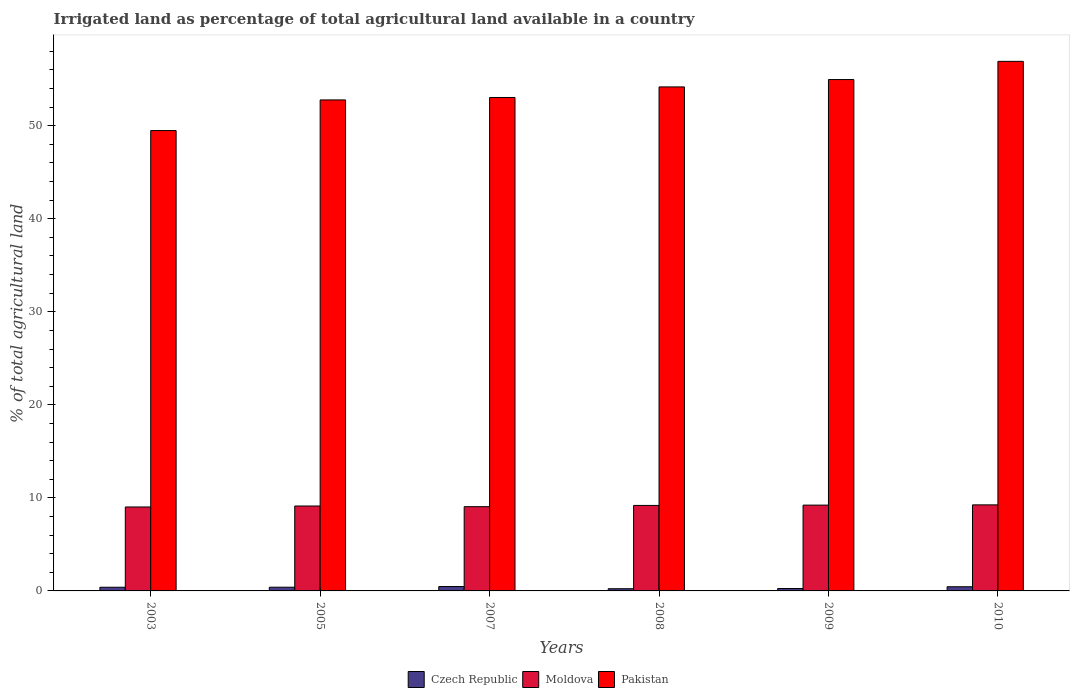How many different coloured bars are there?
Provide a succinct answer. 3. How many groups of bars are there?
Provide a short and direct response. 6. How many bars are there on the 3rd tick from the left?
Give a very brief answer. 3. What is the percentage of irrigated land in Pakistan in 2005?
Make the answer very short. 52.77. Across all years, what is the maximum percentage of irrigated land in Czech Republic?
Keep it short and to the point. 0.47. Across all years, what is the minimum percentage of irrigated land in Pakistan?
Offer a terse response. 49.48. What is the total percentage of irrigated land in Moldova in the graph?
Make the answer very short. 54.87. What is the difference between the percentage of irrigated land in Pakistan in 2008 and that in 2009?
Offer a terse response. -0.79. What is the difference between the percentage of irrigated land in Czech Republic in 2005 and the percentage of irrigated land in Moldova in 2003?
Offer a very short reply. -8.62. What is the average percentage of irrigated land in Pakistan per year?
Offer a terse response. 53.56. In the year 2007, what is the difference between the percentage of irrigated land in Pakistan and percentage of irrigated land in Moldova?
Your response must be concise. 43.98. In how many years, is the percentage of irrigated land in Moldova greater than 18 %?
Give a very brief answer. 0. What is the ratio of the percentage of irrigated land in Moldova in 2008 to that in 2009?
Your answer should be very brief. 1. Is the difference between the percentage of irrigated land in Pakistan in 2005 and 2010 greater than the difference between the percentage of irrigated land in Moldova in 2005 and 2010?
Your answer should be compact. No. What is the difference between the highest and the second highest percentage of irrigated land in Moldova?
Give a very brief answer. 0.03. What is the difference between the highest and the lowest percentage of irrigated land in Moldova?
Provide a succinct answer. 0.23. In how many years, is the percentage of irrigated land in Pakistan greater than the average percentage of irrigated land in Pakistan taken over all years?
Your answer should be compact. 3. What does the 1st bar from the left in 2003 represents?
Provide a succinct answer. Czech Republic. What does the 3rd bar from the right in 2003 represents?
Ensure brevity in your answer.  Czech Republic. How many bars are there?
Provide a short and direct response. 18. How many years are there in the graph?
Give a very brief answer. 6. Does the graph contain any zero values?
Ensure brevity in your answer.  No. Does the graph contain grids?
Provide a short and direct response. No. Where does the legend appear in the graph?
Make the answer very short. Bottom center. How many legend labels are there?
Provide a short and direct response. 3. What is the title of the graph?
Your answer should be compact. Irrigated land as percentage of total agricultural land available in a country. What is the label or title of the Y-axis?
Provide a short and direct response. % of total agricultural land. What is the % of total agricultural land of Czech Republic in 2003?
Make the answer very short. 0.4. What is the % of total agricultural land in Moldova in 2003?
Your answer should be very brief. 9.02. What is the % of total agricultural land of Pakistan in 2003?
Your answer should be very brief. 49.48. What is the % of total agricultural land of Czech Republic in 2005?
Your response must be concise. 0.4. What is the % of total agricultural land of Moldova in 2005?
Offer a terse response. 9.13. What is the % of total agricultural land of Pakistan in 2005?
Your answer should be very brief. 52.77. What is the % of total agricultural land of Czech Republic in 2007?
Ensure brevity in your answer.  0.47. What is the % of total agricultural land in Moldova in 2007?
Make the answer very short. 9.05. What is the % of total agricultural land in Pakistan in 2007?
Keep it short and to the point. 53.04. What is the % of total agricultural land of Czech Republic in 2008?
Provide a succinct answer. 0.24. What is the % of total agricultural land of Moldova in 2008?
Your answer should be compact. 9.19. What is the % of total agricultural land of Pakistan in 2008?
Your answer should be compact. 54.17. What is the % of total agricultural land in Czech Republic in 2009?
Your answer should be very brief. 0.26. What is the % of total agricultural land of Moldova in 2009?
Ensure brevity in your answer.  9.22. What is the % of total agricultural land in Pakistan in 2009?
Your answer should be very brief. 54.96. What is the % of total agricultural land of Czech Republic in 2010?
Keep it short and to the point. 0.45. What is the % of total agricultural land of Moldova in 2010?
Provide a short and direct response. 9.25. What is the % of total agricultural land of Pakistan in 2010?
Make the answer very short. 56.92. Across all years, what is the maximum % of total agricultural land in Czech Republic?
Provide a short and direct response. 0.47. Across all years, what is the maximum % of total agricultural land of Moldova?
Your response must be concise. 9.25. Across all years, what is the maximum % of total agricultural land in Pakistan?
Give a very brief answer. 56.92. Across all years, what is the minimum % of total agricultural land of Czech Republic?
Provide a succinct answer. 0.24. Across all years, what is the minimum % of total agricultural land of Moldova?
Provide a short and direct response. 9.02. Across all years, what is the minimum % of total agricultural land of Pakistan?
Keep it short and to the point. 49.48. What is the total % of total agricultural land of Czech Republic in the graph?
Offer a terse response. 2.21. What is the total % of total agricultural land in Moldova in the graph?
Give a very brief answer. 54.87. What is the total % of total agricultural land of Pakistan in the graph?
Offer a very short reply. 321.35. What is the difference between the % of total agricultural land in Czech Republic in 2003 and that in 2005?
Keep it short and to the point. -0. What is the difference between the % of total agricultural land of Moldova in 2003 and that in 2005?
Ensure brevity in your answer.  -0.1. What is the difference between the % of total agricultural land in Pakistan in 2003 and that in 2005?
Ensure brevity in your answer.  -3.29. What is the difference between the % of total agricultural land of Czech Republic in 2003 and that in 2007?
Your answer should be very brief. -0.07. What is the difference between the % of total agricultural land in Moldova in 2003 and that in 2007?
Offer a very short reply. -0.03. What is the difference between the % of total agricultural land of Pakistan in 2003 and that in 2007?
Offer a very short reply. -3.55. What is the difference between the % of total agricultural land of Czech Republic in 2003 and that in 2008?
Keep it short and to the point. 0.16. What is the difference between the % of total agricultural land in Moldova in 2003 and that in 2008?
Provide a succinct answer. -0.17. What is the difference between the % of total agricultural land in Pakistan in 2003 and that in 2008?
Provide a succinct answer. -4.69. What is the difference between the % of total agricultural land of Czech Republic in 2003 and that in 2009?
Ensure brevity in your answer.  0.14. What is the difference between the % of total agricultural land of Moldova in 2003 and that in 2009?
Your answer should be very brief. -0.2. What is the difference between the % of total agricultural land of Pakistan in 2003 and that in 2009?
Offer a terse response. -5.48. What is the difference between the % of total agricultural land of Czech Republic in 2003 and that in 2010?
Your answer should be compact. -0.05. What is the difference between the % of total agricultural land of Moldova in 2003 and that in 2010?
Offer a very short reply. -0.23. What is the difference between the % of total agricultural land of Pakistan in 2003 and that in 2010?
Your response must be concise. -7.44. What is the difference between the % of total agricultural land of Czech Republic in 2005 and that in 2007?
Your response must be concise. -0.07. What is the difference between the % of total agricultural land in Moldova in 2005 and that in 2007?
Make the answer very short. 0.07. What is the difference between the % of total agricultural land in Pakistan in 2005 and that in 2007?
Keep it short and to the point. -0.26. What is the difference between the % of total agricultural land of Czech Republic in 2005 and that in 2008?
Your response must be concise. 0.16. What is the difference between the % of total agricultural land in Moldova in 2005 and that in 2008?
Offer a terse response. -0.06. What is the difference between the % of total agricultural land of Pakistan in 2005 and that in 2008?
Provide a succinct answer. -1.4. What is the difference between the % of total agricultural land of Czech Republic in 2005 and that in 2009?
Your response must be concise. 0.14. What is the difference between the % of total agricultural land of Moldova in 2005 and that in 2009?
Your answer should be compact. -0.1. What is the difference between the % of total agricultural land in Pakistan in 2005 and that in 2009?
Keep it short and to the point. -2.19. What is the difference between the % of total agricultural land of Czech Republic in 2005 and that in 2010?
Your answer should be compact. -0.05. What is the difference between the % of total agricultural land of Moldova in 2005 and that in 2010?
Your response must be concise. -0.12. What is the difference between the % of total agricultural land of Pakistan in 2005 and that in 2010?
Offer a very short reply. -4.15. What is the difference between the % of total agricultural land in Czech Republic in 2007 and that in 2008?
Offer a very short reply. 0.24. What is the difference between the % of total agricultural land in Moldova in 2007 and that in 2008?
Your response must be concise. -0.14. What is the difference between the % of total agricultural land in Pakistan in 2007 and that in 2008?
Your answer should be compact. -1.14. What is the difference between the % of total agricultural land in Czech Republic in 2007 and that in 2009?
Give a very brief answer. 0.21. What is the difference between the % of total agricultural land in Moldova in 2007 and that in 2009?
Offer a terse response. -0.17. What is the difference between the % of total agricultural land of Pakistan in 2007 and that in 2009?
Ensure brevity in your answer.  -1.93. What is the difference between the % of total agricultural land of Czech Republic in 2007 and that in 2010?
Your answer should be compact. 0.02. What is the difference between the % of total agricultural land in Moldova in 2007 and that in 2010?
Offer a very short reply. -0.2. What is the difference between the % of total agricultural land of Pakistan in 2007 and that in 2010?
Give a very brief answer. -3.88. What is the difference between the % of total agricultural land of Czech Republic in 2008 and that in 2009?
Your response must be concise. -0.02. What is the difference between the % of total agricultural land of Moldova in 2008 and that in 2009?
Your answer should be very brief. -0.03. What is the difference between the % of total agricultural land of Pakistan in 2008 and that in 2009?
Provide a succinct answer. -0.79. What is the difference between the % of total agricultural land in Czech Republic in 2008 and that in 2010?
Give a very brief answer. -0.21. What is the difference between the % of total agricultural land in Moldova in 2008 and that in 2010?
Your response must be concise. -0.06. What is the difference between the % of total agricultural land of Pakistan in 2008 and that in 2010?
Your response must be concise. -2.75. What is the difference between the % of total agricultural land in Czech Republic in 2009 and that in 2010?
Offer a terse response. -0.19. What is the difference between the % of total agricultural land in Moldova in 2009 and that in 2010?
Provide a succinct answer. -0.03. What is the difference between the % of total agricultural land of Pakistan in 2009 and that in 2010?
Make the answer very short. -1.96. What is the difference between the % of total agricultural land in Czech Republic in 2003 and the % of total agricultural land in Moldova in 2005?
Your answer should be compact. -8.73. What is the difference between the % of total agricultural land in Czech Republic in 2003 and the % of total agricultural land in Pakistan in 2005?
Offer a terse response. -52.38. What is the difference between the % of total agricultural land in Moldova in 2003 and the % of total agricultural land in Pakistan in 2005?
Offer a very short reply. -43.75. What is the difference between the % of total agricultural land of Czech Republic in 2003 and the % of total agricultural land of Moldova in 2007?
Your response must be concise. -8.66. What is the difference between the % of total agricultural land in Czech Republic in 2003 and the % of total agricultural land in Pakistan in 2007?
Make the answer very short. -52.64. What is the difference between the % of total agricultural land of Moldova in 2003 and the % of total agricultural land of Pakistan in 2007?
Ensure brevity in your answer.  -44.01. What is the difference between the % of total agricultural land in Czech Republic in 2003 and the % of total agricultural land in Moldova in 2008?
Your response must be concise. -8.79. What is the difference between the % of total agricultural land in Czech Republic in 2003 and the % of total agricultural land in Pakistan in 2008?
Offer a terse response. -53.78. What is the difference between the % of total agricultural land of Moldova in 2003 and the % of total agricultural land of Pakistan in 2008?
Give a very brief answer. -45.15. What is the difference between the % of total agricultural land of Czech Republic in 2003 and the % of total agricultural land of Moldova in 2009?
Provide a succinct answer. -8.83. What is the difference between the % of total agricultural land in Czech Republic in 2003 and the % of total agricultural land in Pakistan in 2009?
Provide a succinct answer. -54.57. What is the difference between the % of total agricultural land of Moldova in 2003 and the % of total agricultural land of Pakistan in 2009?
Offer a terse response. -45.94. What is the difference between the % of total agricultural land in Czech Republic in 2003 and the % of total agricultural land in Moldova in 2010?
Keep it short and to the point. -8.85. What is the difference between the % of total agricultural land of Czech Republic in 2003 and the % of total agricultural land of Pakistan in 2010?
Make the answer very short. -56.52. What is the difference between the % of total agricultural land in Moldova in 2003 and the % of total agricultural land in Pakistan in 2010?
Keep it short and to the point. -47.9. What is the difference between the % of total agricultural land of Czech Republic in 2005 and the % of total agricultural land of Moldova in 2007?
Make the answer very short. -8.66. What is the difference between the % of total agricultural land in Czech Republic in 2005 and the % of total agricultural land in Pakistan in 2007?
Ensure brevity in your answer.  -52.64. What is the difference between the % of total agricultural land in Moldova in 2005 and the % of total agricultural land in Pakistan in 2007?
Your answer should be very brief. -43.91. What is the difference between the % of total agricultural land in Czech Republic in 2005 and the % of total agricultural land in Moldova in 2008?
Make the answer very short. -8.79. What is the difference between the % of total agricultural land in Czech Republic in 2005 and the % of total agricultural land in Pakistan in 2008?
Provide a succinct answer. -53.77. What is the difference between the % of total agricultural land in Moldova in 2005 and the % of total agricultural land in Pakistan in 2008?
Your answer should be compact. -45.05. What is the difference between the % of total agricultural land in Czech Republic in 2005 and the % of total agricultural land in Moldova in 2009?
Offer a very short reply. -8.82. What is the difference between the % of total agricultural land of Czech Republic in 2005 and the % of total agricultural land of Pakistan in 2009?
Offer a terse response. -54.57. What is the difference between the % of total agricultural land in Moldova in 2005 and the % of total agricultural land in Pakistan in 2009?
Your response must be concise. -45.84. What is the difference between the % of total agricultural land in Czech Republic in 2005 and the % of total agricultural land in Moldova in 2010?
Provide a short and direct response. -8.85. What is the difference between the % of total agricultural land in Czech Republic in 2005 and the % of total agricultural land in Pakistan in 2010?
Your answer should be compact. -56.52. What is the difference between the % of total agricultural land of Moldova in 2005 and the % of total agricultural land of Pakistan in 2010?
Provide a short and direct response. -47.79. What is the difference between the % of total agricultural land in Czech Republic in 2007 and the % of total agricultural land in Moldova in 2008?
Provide a short and direct response. -8.72. What is the difference between the % of total agricultural land in Czech Republic in 2007 and the % of total agricultural land in Pakistan in 2008?
Ensure brevity in your answer.  -53.7. What is the difference between the % of total agricultural land of Moldova in 2007 and the % of total agricultural land of Pakistan in 2008?
Give a very brief answer. -45.12. What is the difference between the % of total agricultural land in Czech Republic in 2007 and the % of total agricultural land in Moldova in 2009?
Provide a short and direct response. -8.75. What is the difference between the % of total agricultural land in Czech Republic in 2007 and the % of total agricultural land in Pakistan in 2009?
Your answer should be compact. -54.49. What is the difference between the % of total agricultural land of Moldova in 2007 and the % of total agricultural land of Pakistan in 2009?
Provide a short and direct response. -45.91. What is the difference between the % of total agricultural land of Czech Republic in 2007 and the % of total agricultural land of Moldova in 2010?
Provide a succinct answer. -8.78. What is the difference between the % of total agricultural land of Czech Republic in 2007 and the % of total agricultural land of Pakistan in 2010?
Provide a short and direct response. -56.45. What is the difference between the % of total agricultural land in Moldova in 2007 and the % of total agricultural land in Pakistan in 2010?
Provide a succinct answer. -47.87. What is the difference between the % of total agricultural land of Czech Republic in 2008 and the % of total agricultural land of Moldova in 2009?
Offer a terse response. -8.99. What is the difference between the % of total agricultural land in Czech Republic in 2008 and the % of total agricultural land in Pakistan in 2009?
Keep it short and to the point. -54.73. What is the difference between the % of total agricultural land in Moldova in 2008 and the % of total agricultural land in Pakistan in 2009?
Offer a very short reply. -45.78. What is the difference between the % of total agricultural land of Czech Republic in 2008 and the % of total agricultural land of Moldova in 2010?
Offer a very short reply. -9.01. What is the difference between the % of total agricultural land in Czech Republic in 2008 and the % of total agricultural land in Pakistan in 2010?
Provide a short and direct response. -56.69. What is the difference between the % of total agricultural land in Moldova in 2008 and the % of total agricultural land in Pakistan in 2010?
Provide a short and direct response. -47.73. What is the difference between the % of total agricultural land in Czech Republic in 2009 and the % of total agricultural land in Moldova in 2010?
Provide a short and direct response. -8.99. What is the difference between the % of total agricultural land in Czech Republic in 2009 and the % of total agricultural land in Pakistan in 2010?
Make the answer very short. -56.66. What is the difference between the % of total agricultural land of Moldova in 2009 and the % of total agricultural land of Pakistan in 2010?
Your answer should be very brief. -47.7. What is the average % of total agricultural land in Czech Republic per year?
Provide a short and direct response. 0.37. What is the average % of total agricultural land of Moldova per year?
Keep it short and to the point. 9.14. What is the average % of total agricultural land in Pakistan per year?
Keep it short and to the point. 53.56. In the year 2003, what is the difference between the % of total agricultural land in Czech Republic and % of total agricultural land in Moldova?
Provide a succinct answer. -8.63. In the year 2003, what is the difference between the % of total agricultural land of Czech Republic and % of total agricultural land of Pakistan?
Ensure brevity in your answer.  -49.09. In the year 2003, what is the difference between the % of total agricultural land in Moldova and % of total agricultural land in Pakistan?
Your response must be concise. -40.46. In the year 2005, what is the difference between the % of total agricultural land in Czech Republic and % of total agricultural land in Moldova?
Keep it short and to the point. -8.73. In the year 2005, what is the difference between the % of total agricultural land in Czech Republic and % of total agricultural land in Pakistan?
Keep it short and to the point. -52.37. In the year 2005, what is the difference between the % of total agricultural land of Moldova and % of total agricultural land of Pakistan?
Ensure brevity in your answer.  -43.65. In the year 2007, what is the difference between the % of total agricultural land in Czech Republic and % of total agricultural land in Moldova?
Ensure brevity in your answer.  -8.58. In the year 2007, what is the difference between the % of total agricultural land in Czech Republic and % of total agricultural land in Pakistan?
Provide a succinct answer. -52.57. In the year 2007, what is the difference between the % of total agricultural land in Moldova and % of total agricultural land in Pakistan?
Your response must be concise. -43.98. In the year 2008, what is the difference between the % of total agricultural land in Czech Republic and % of total agricultural land in Moldova?
Offer a terse response. -8.95. In the year 2008, what is the difference between the % of total agricultural land in Czech Republic and % of total agricultural land in Pakistan?
Provide a short and direct response. -53.94. In the year 2008, what is the difference between the % of total agricultural land of Moldova and % of total agricultural land of Pakistan?
Your answer should be compact. -44.98. In the year 2009, what is the difference between the % of total agricultural land of Czech Republic and % of total agricultural land of Moldova?
Offer a terse response. -8.96. In the year 2009, what is the difference between the % of total agricultural land in Czech Republic and % of total agricultural land in Pakistan?
Ensure brevity in your answer.  -54.71. In the year 2009, what is the difference between the % of total agricultural land in Moldova and % of total agricultural land in Pakistan?
Ensure brevity in your answer.  -45.74. In the year 2010, what is the difference between the % of total agricultural land in Czech Republic and % of total agricultural land in Moldova?
Your answer should be very brief. -8.8. In the year 2010, what is the difference between the % of total agricultural land in Czech Republic and % of total agricultural land in Pakistan?
Give a very brief answer. -56.47. In the year 2010, what is the difference between the % of total agricultural land of Moldova and % of total agricultural land of Pakistan?
Offer a terse response. -47.67. What is the ratio of the % of total agricultural land in Czech Republic in 2003 to that in 2005?
Provide a succinct answer. 0.99. What is the ratio of the % of total agricultural land in Moldova in 2003 to that in 2005?
Your answer should be compact. 0.99. What is the ratio of the % of total agricultural land of Pakistan in 2003 to that in 2005?
Keep it short and to the point. 0.94. What is the ratio of the % of total agricultural land of Czech Republic in 2003 to that in 2007?
Offer a terse response. 0.84. What is the ratio of the % of total agricultural land in Moldova in 2003 to that in 2007?
Your answer should be compact. 1. What is the ratio of the % of total agricultural land in Pakistan in 2003 to that in 2007?
Your answer should be very brief. 0.93. What is the ratio of the % of total agricultural land of Czech Republic in 2003 to that in 2008?
Offer a very short reply. 1.68. What is the ratio of the % of total agricultural land in Moldova in 2003 to that in 2008?
Provide a short and direct response. 0.98. What is the ratio of the % of total agricultural land of Pakistan in 2003 to that in 2008?
Provide a short and direct response. 0.91. What is the ratio of the % of total agricultural land in Czech Republic in 2003 to that in 2009?
Offer a terse response. 1.53. What is the ratio of the % of total agricultural land of Moldova in 2003 to that in 2009?
Make the answer very short. 0.98. What is the ratio of the % of total agricultural land of Pakistan in 2003 to that in 2009?
Keep it short and to the point. 0.9. What is the ratio of the % of total agricultural land of Czech Republic in 2003 to that in 2010?
Your response must be concise. 0.88. What is the ratio of the % of total agricultural land in Moldova in 2003 to that in 2010?
Offer a terse response. 0.98. What is the ratio of the % of total agricultural land in Pakistan in 2003 to that in 2010?
Your answer should be very brief. 0.87. What is the ratio of the % of total agricultural land of Czech Republic in 2005 to that in 2007?
Give a very brief answer. 0.85. What is the ratio of the % of total agricultural land of Czech Republic in 2005 to that in 2008?
Offer a terse response. 1.69. What is the ratio of the % of total agricultural land in Moldova in 2005 to that in 2008?
Your response must be concise. 0.99. What is the ratio of the % of total agricultural land in Pakistan in 2005 to that in 2008?
Your answer should be very brief. 0.97. What is the ratio of the % of total agricultural land in Czech Republic in 2005 to that in 2009?
Keep it short and to the point. 1.54. What is the ratio of the % of total agricultural land of Pakistan in 2005 to that in 2009?
Offer a very short reply. 0.96. What is the ratio of the % of total agricultural land in Czech Republic in 2005 to that in 2010?
Give a very brief answer. 0.89. What is the ratio of the % of total agricultural land in Moldova in 2005 to that in 2010?
Provide a short and direct response. 0.99. What is the ratio of the % of total agricultural land of Pakistan in 2005 to that in 2010?
Your response must be concise. 0.93. What is the ratio of the % of total agricultural land in Czech Republic in 2007 to that in 2008?
Your answer should be compact. 2. What is the ratio of the % of total agricultural land of Pakistan in 2007 to that in 2008?
Keep it short and to the point. 0.98. What is the ratio of the % of total agricultural land in Czech Republic in 2007 to that in 2009?
Make the answer very short. 1.81. What is the ratio of the % of total agricultural land in Moldova in 2007 to that in 2009?
Keep it short and to the point. 0.98. What is the ratio of the % of total agricultural land of Pakistan in 2007 to that in 2009?
Make the answer very short. 0.96. What is the ratio of the % of total agricultural land of Czech Republic in 2007 to that in 2010?
Your response must be concise. 1.05. What is the ratio of the % of total agricultural land in Moldova in 2007 to that in 2010?
Keep it short and to the point. 0.98. What is the ratio of the % of total agricultural land of Pakistan in 2007 to that in 2010?
Provide a succinct answer. 0.93. What is the ratio of the % of total agricultural land in Czech Republic in 2008 to that in 2009?
Provide a short and direct response. 0.91. What is the ratio of the % of total agricultural land in Moldova in 2008 to that in 2009?
Offer a terse response. 1. What is the ratio of the % of total agricultural land in Pakistan in 2008 to that in 2009?
Your response must be concise. 0.99. What is the ratio of the % of total agricultural land in Czech Republic in 2008 to that in 2010?
Offer a terse response. 0.53. What is the ratio of the % of total agricultural land in Pakistan in 2008 to that in 2010?
Make the answer very short. 0.95. What is the ratio of the % of total agricultural land in Czech Republic in 2009 to that in 2010?
Provide a short and direct response. 0.58. What is the ratio of the % of total agricultural land in Pakistan in 2009 to that in 2010?
Offer a terse response. 0.97. What is the difference between the highest and the second highest % of total agricultural land in Czech Republic?
Ensure brevity in your answer.  0.02. What is the difference between the highest and the second highest % of total agricultural land of Moldova?
Offer a terse response. 0.03. What is the difference between the highest and the second highest % of total agricultural land in Pakistan?
Your response must be concise. 1.96. What is the difference between the highest and the lowest % of total agricultural land of Czech Republic?
Ensure brevity in your answer.  0.24. What is the difference between the highest and the lowest % of total agricultural land in Moldova?
Provide a short and direct response. 0.23. What is the difference between the highest and the lowest % of total agricultural land of Pakistan?
Provide a short and direct response. 7.44. 